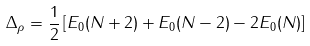Convert formula to latex. <formula><loc_0><loc_0><loc_500><loc_500>\Delta _ { \rho } = \frac { 1 } { 2 } \left [ E _ { 0 } ( N + 2 ) + E _ { 0 } ( N - 2 ) - 2 E _ { 0 } ( N ) \right ]</formula> 